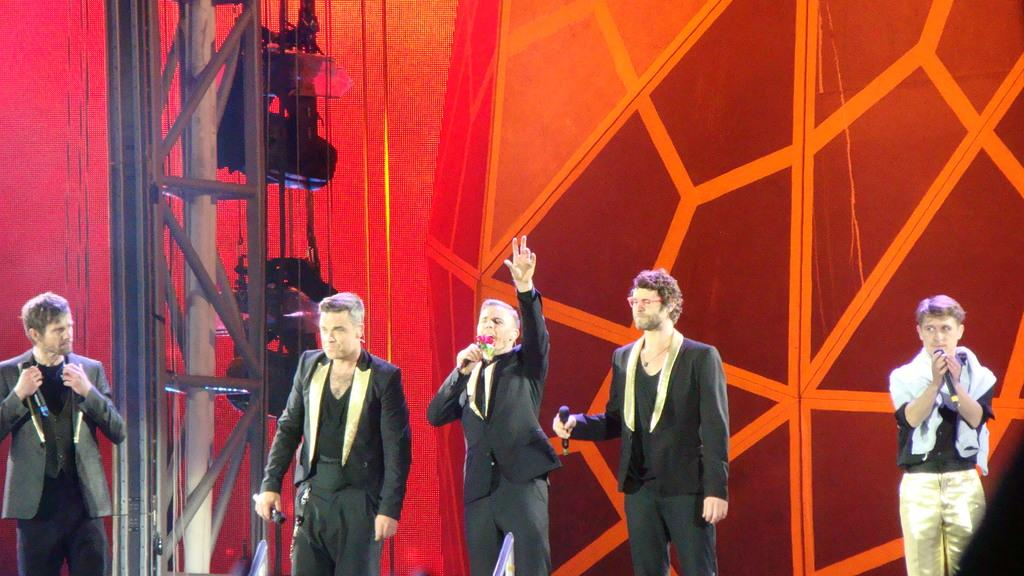How many people are in the image? There is a group of persons in the image. What are the people in the image doing? The persons are standing. What are the people wearing in the image? The persons are wearing clothes. What can be seen on the left side of the image? There is a pole on the left side of the image. What action is one person at the bottom of the image performing? One person at the bottom of the image is raising a hand. What type of milk is being served to the horses in the image? There are no horses or milk present in the image. How many pizzas are being shared among the group of persons in the image? There is no mention of pizzas in the image; it only shows a group of standing persons. 